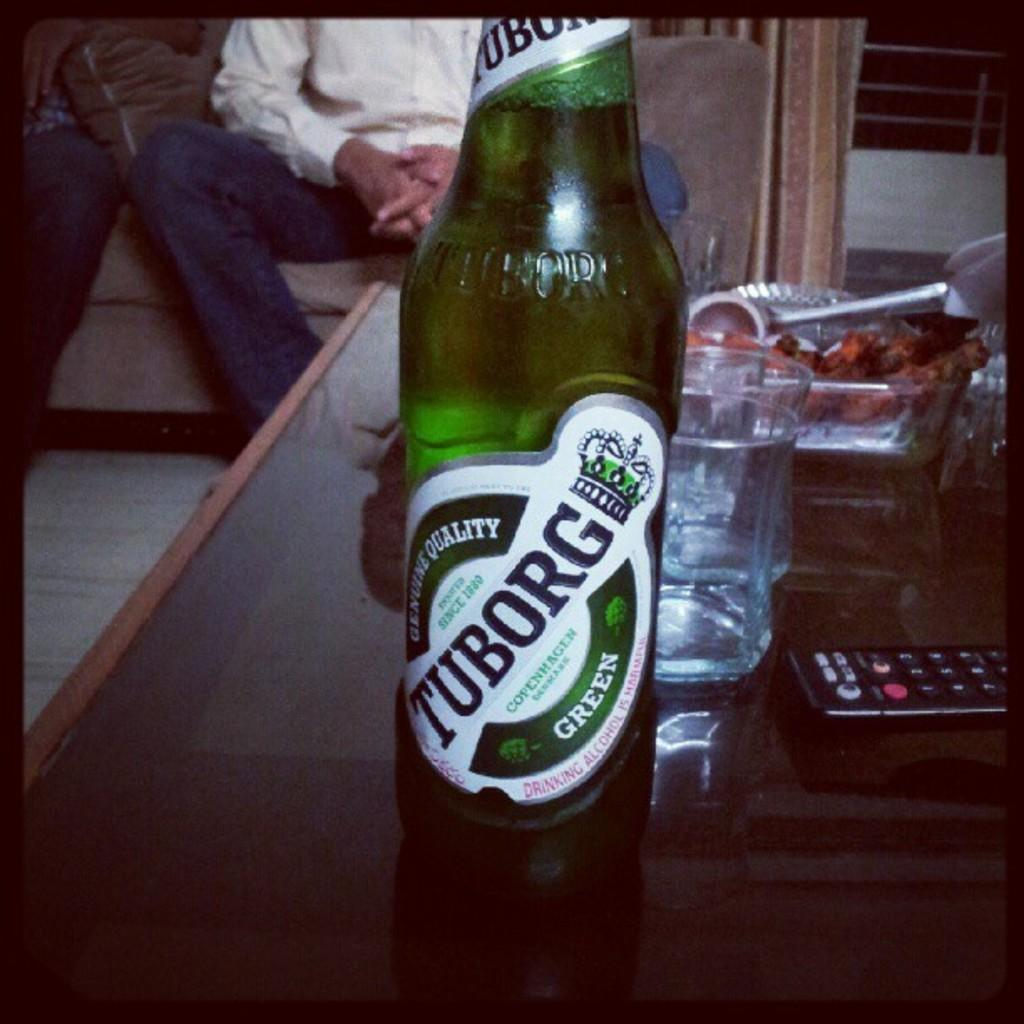<image>
Create a compact narrative representing the image presented. A Tuborg Green bottle of beer on a coffee table. 